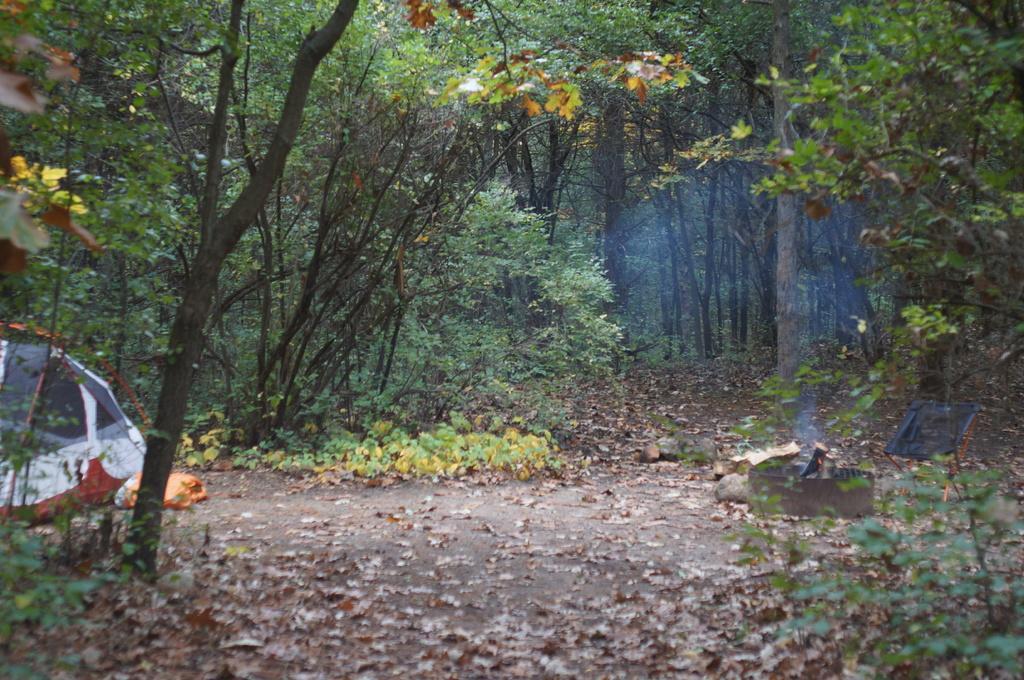How would you summarize this image in a sentence or two? In the image there is a tent on the left side and behind there are plants all over the land with dry leaves on it. 